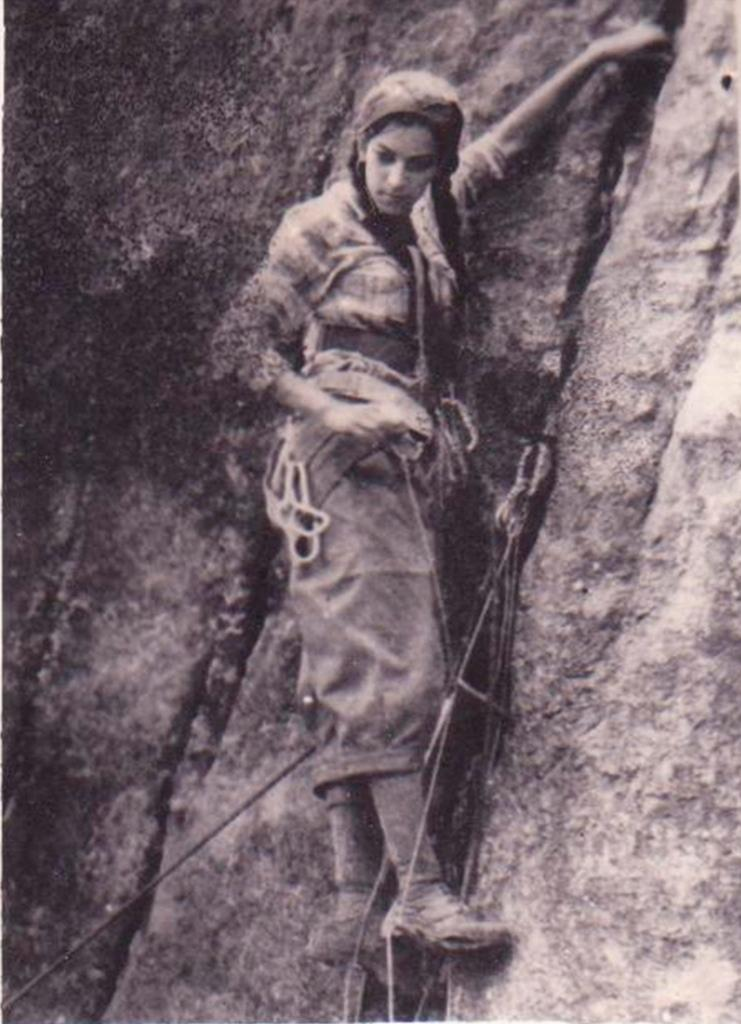What is the color scheme of the image? The image is black and white. Who is present in the image? There is a woman in the image. What is the woman holding in the image? The woman is holding a rope. What can be seen in the background of the image? Rocks are visible in the background of the image. Is there another rope visible in the image? Yes, there is a rope in the background of the image. What type of vest is the woman wearing in the image? There is no vest visible in the image; the woman is wearing a dress. What tool is the woman using to fix the wrench in the image? There is no wrench present in the image, and the woman is not using any tools. 